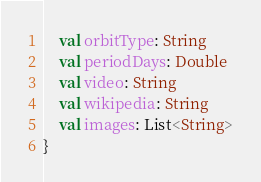Convert code to text. <code><loc_0><loc_0><loc_500><loc_500><_Kotlin_>    val orbitType: String
    val periodDays: Double
    val video: String
    val wikipedia: String
    val images: List<String>
}</code> 